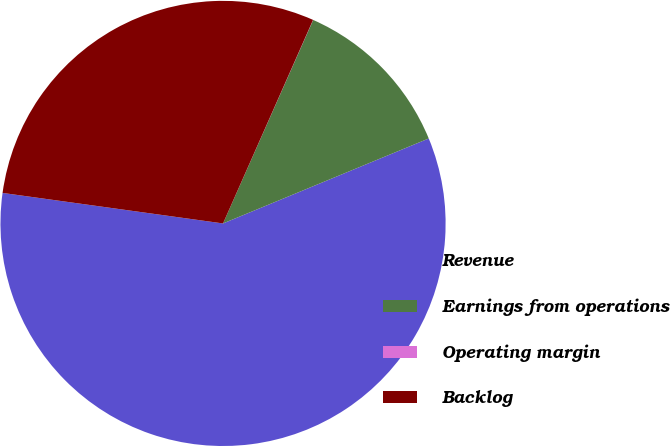Convert chart. <chart><loc_0><loc_0><loc_500><loc_500><pie_chart><fcel>Revenue<fcel>Earnings from operations<fcel>Operating margin<fcel>Backlog<nl><fcel>58.43%<fcel>12.13%<fcel>0.01%<fcel>29.44%<nl></chart> 